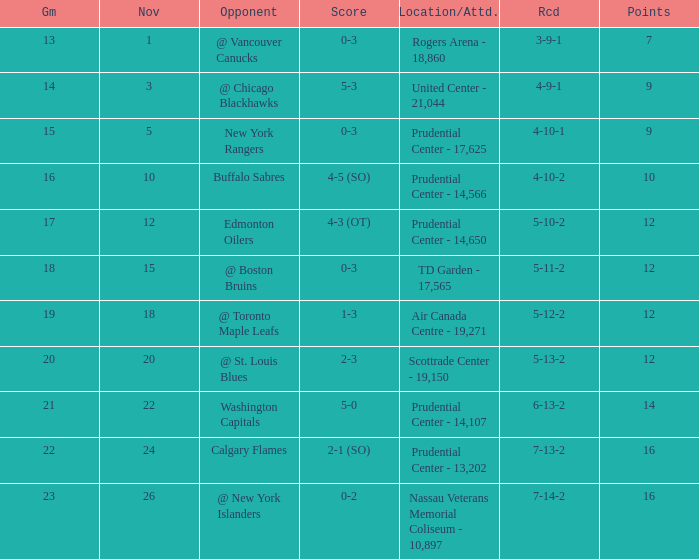What is the record for score 1-3? 5-12-2. Can you parse all the data within this table? {'header': ['Gm', 'Nov', 'Opponent', 'Score', 'Location/Attd.', 'Rcd', 'Points'], 'rows': [['13', '1', '@ Vancouver Canucks', '0-3', 'Rogers Arena - 18,860', '3-9-1', '7'], ['14', '3', '@ Chicago Blackhawks', '5-3', 'United Center - 21,044', '4-9-1', '9'], ['15', '5', 'New York Rangers', '0-3', 'Prudential Center - 17,625', '4-10-1', '9'], ['16', '10', 'Buffalo Sabres', '4-5 (SO)', 'Prudential Center - 14,566', '4-10-2', '10'], ['17', '12', 'Edmonton Oilers', '4-3 (OT)', 'Prudential Center - 14,650', '5-10-2', '12'], ['18', '15', '@ Boston Bruins', '0-3', 'TD Garden - 17,565', '5-11-2', '12'], ['19', '18', '@ Toronto Maple Leafs', '1-3', 'Air Canada Centre - 19,271', '5-12-2', '12'], ['20', '20', '@ St. Louis Blues', '2-3', 'Scottrade Center - 19,150', '5-13-2', '12'], ['21', '22', 'Washington Capitals', '5-0', 'Prudential Center - 14,107', '6-13-2', '14'], ['22', '24', 'Calgary Flames', '2-1 (SO)', 'Prudential Center - 13,202', '7-13-2', '16'], ['23', '26', '@ New York Islanders', '0-2', 'Nassau Veterans Memorial Coliseum - 10,897', '7-14-2', '16']]} 